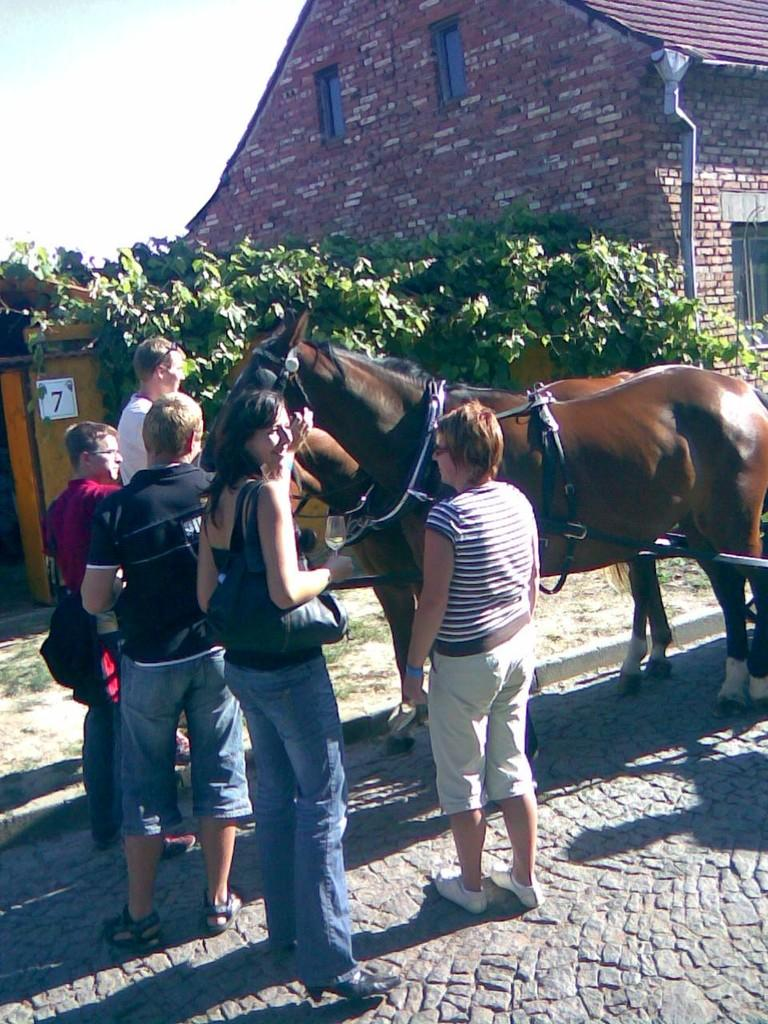What is happening in the foreground of the image? There are people standing in front of a horse. What can be seen in the background of the image? There is a building and plants visible in the background. What type of bubble is being played by the person on the left side of the image? There is no bubble present in the image; it features people standing in front of a horse with a building and plants visible in the background. Can you tell me which instrument the person on the right side of the image is holding? There is no instrument present in the image; it features people standing in front of a horse with a building and plants visible in the background. 